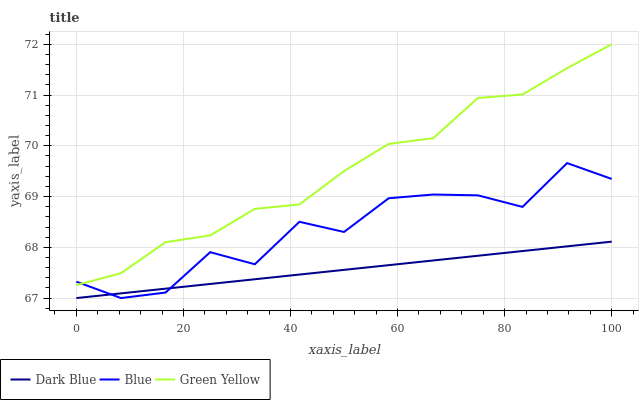Does Dark Blue have the minimum area under the curve?
Answer yes or no. Yes. Does Green Yellow have the maximum area under the curve?
Answer yes or no. Yes. Does Green Yellow have the minimum area under the curve?
Answer yes or no. No. Does Dark Blue have the maximum area under the curve?
Answer yes or no. No. Is Dark Blue the smoothest?
Answer yes or no. Yes. Is Blue the roughest?
Answer yes or no. Yes. Is Green Yellow the smoothest?
Answer yes or no. No. Is Green Yellow the roughest?
Answer yes or no. No. Does Blue have the lowest value?
Answer yes or no. Yes. Does Green Yellow have the lowest value?
Answer yes or no. No. Does Green Yellow have the highest value?
Answer yes or no. Yes. Does Dark Blue have the highest value?
Answer yes or no. No. Is Dark Blue less than Green Yellow?
Answer yes or no. Yes. Is Green Yellow greater than Dark Blue?
Answer yes or no. Yes. Does Blue intersect Dark Blue?
Answer yes or no. Yes. Is Blue less than Dark Blue?
Answer yes or no. No. Is Blue greater than Dark Blue?
Answer yes or no. No. Does Dark Blue intersect Green Yellow?
Answer yes or no. No. 